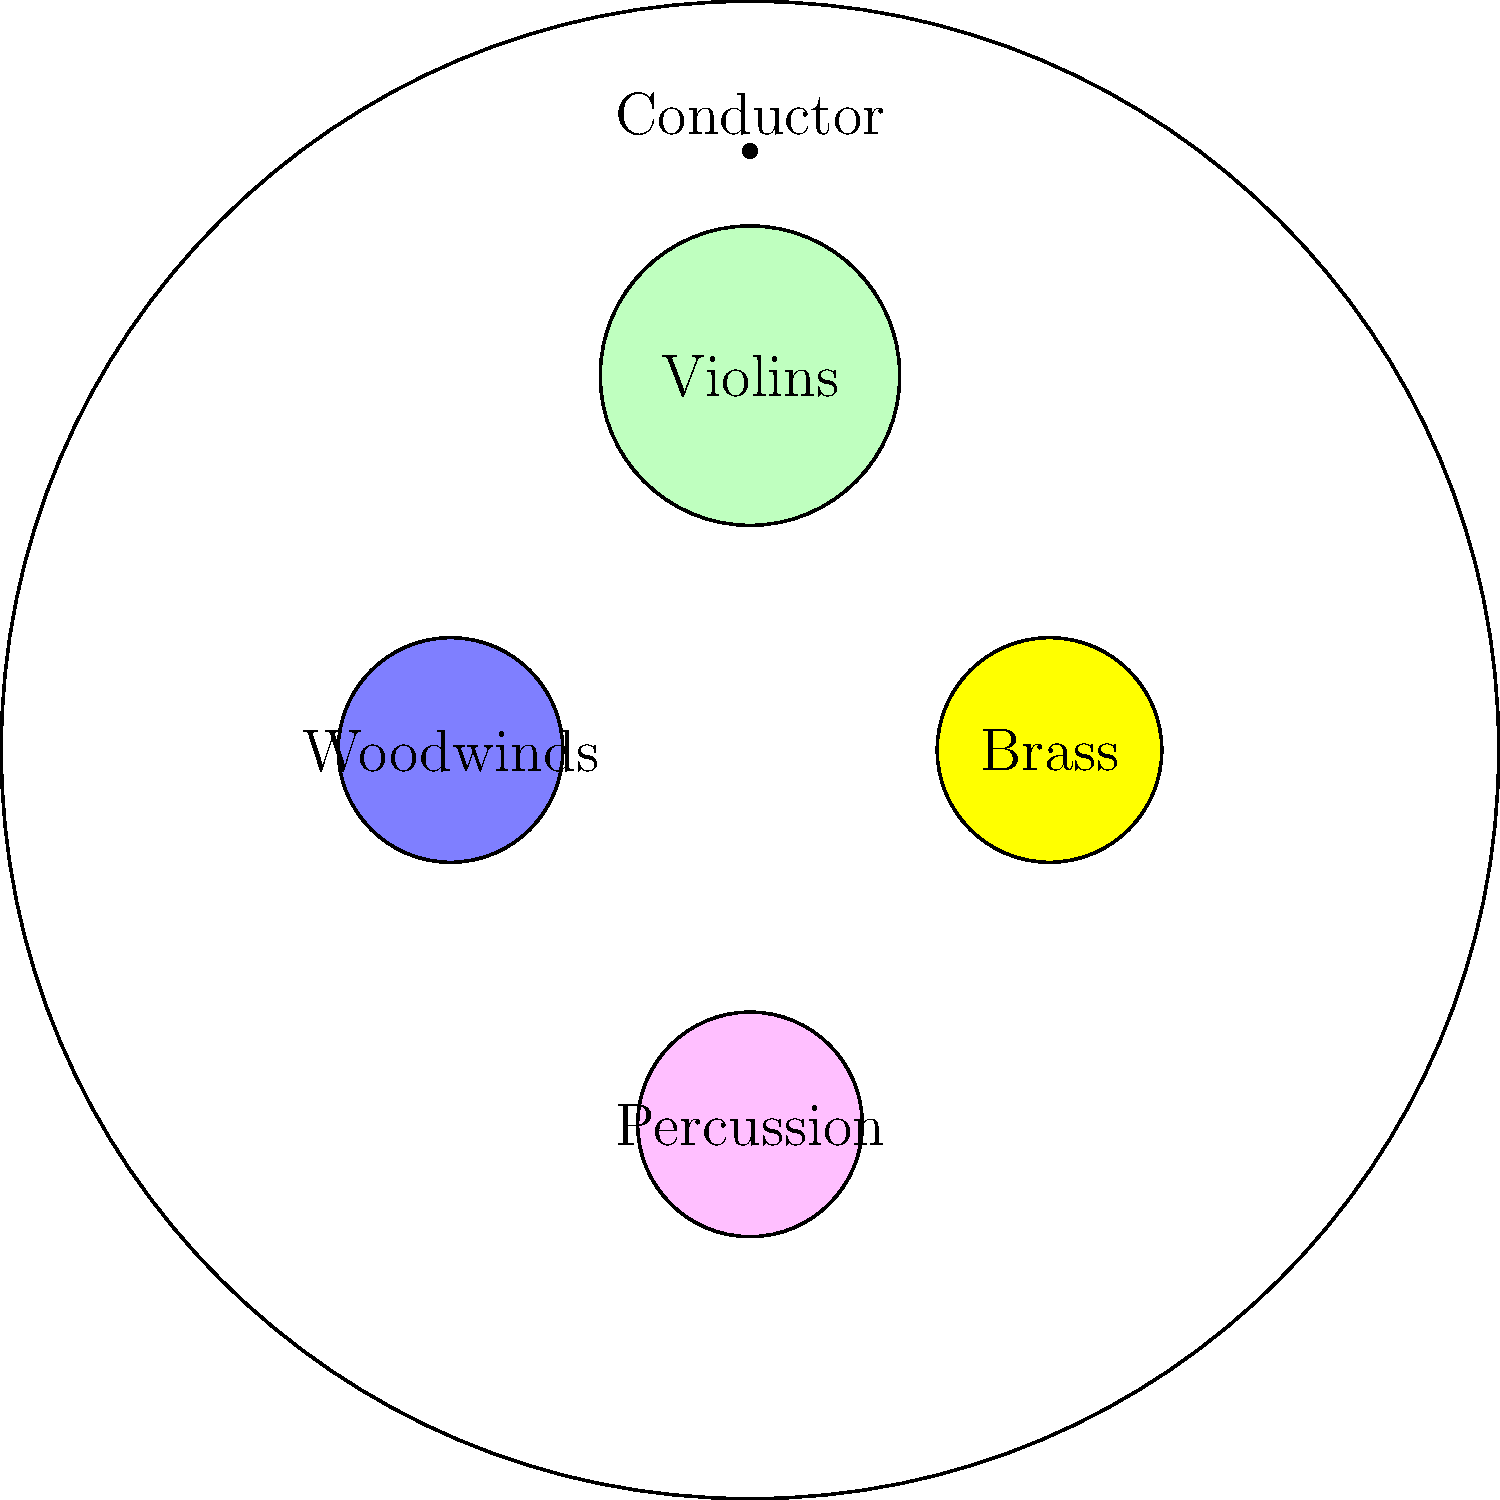In this orchestral seating chart, which section is typically positioned directly behind the conductor and is represented by the largest circle? To answer this question, let's analyze the orchestral seating chart step-by-step:

1. The chart shows a circular stage with four main sections represented by colored circles.
2. The conductor is positioned at the top of the chart, facing the orchestra.
3. Directly behind the conductor, we see the largest circle colored in pale green.
4. This large, centrally-located section is labeled "Violins".
5. The other sections are smaller and positioned to the sides (Woodwinds and Brass) or at the back (Percussion) of the orchestra.
6. In a typical orchestral setup, the string section, particularly the violins, occupies the largest area and is positioned directly in front of the conductor.

Therefore, the section directly behind the conductor, represented by the largest circle, is the violin section, which is part of the larger string section in an orchestra.
Answer: Violins (String section) 